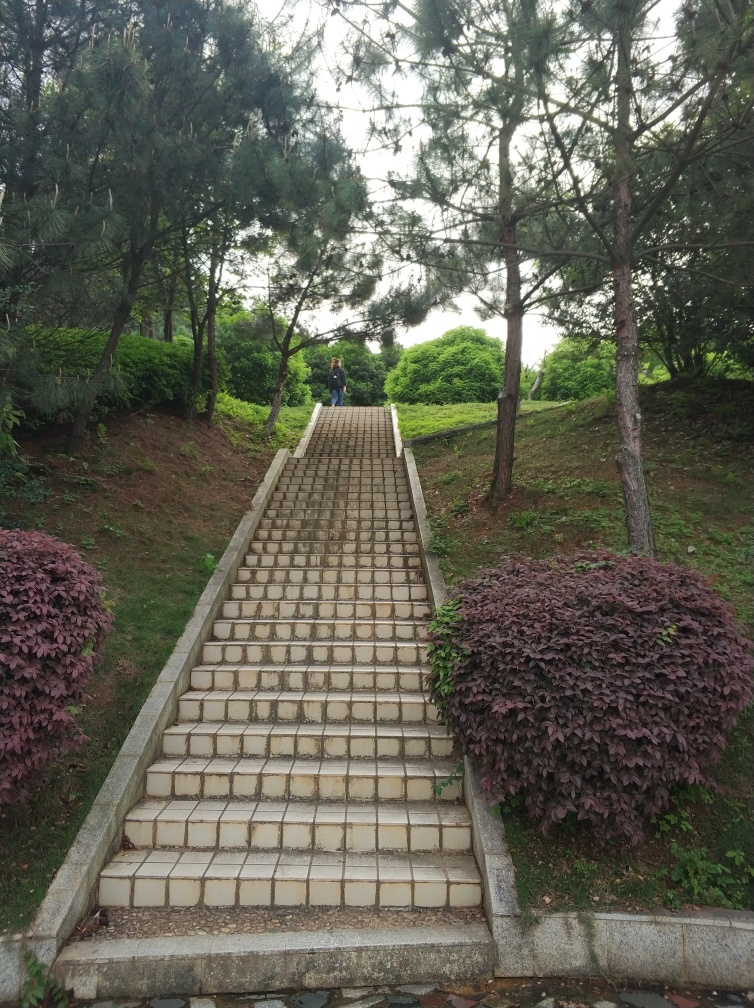Can you describe the design and layout of the staircase in this image? Certainly! The staircase in the image has a straight, ascending design leading upwards between two patches of lush greenery. It consists of uniform rectangular tiling patterns, bordered by a simple concrete balustrade. This functional design ensures easy accessibility while harmoniously blending with the natural surroundings. 